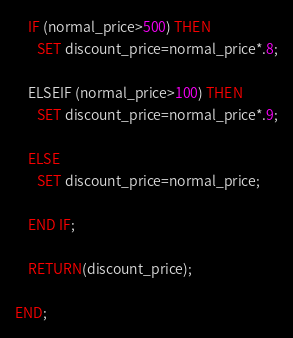<code> <loc_0><loc_0><loc_500><loc_500><_SQL_>    IF (normal_price>500) THEN
       SET discount_price=normal_price*.8;

    ELSEIF (normal_price>100) THEN
       SET discount_price=normal_price*.9;

    ELSE
       SET discount_price=normal_price;

    END IF;

    RETURN(discount_price);

END;
</code> 